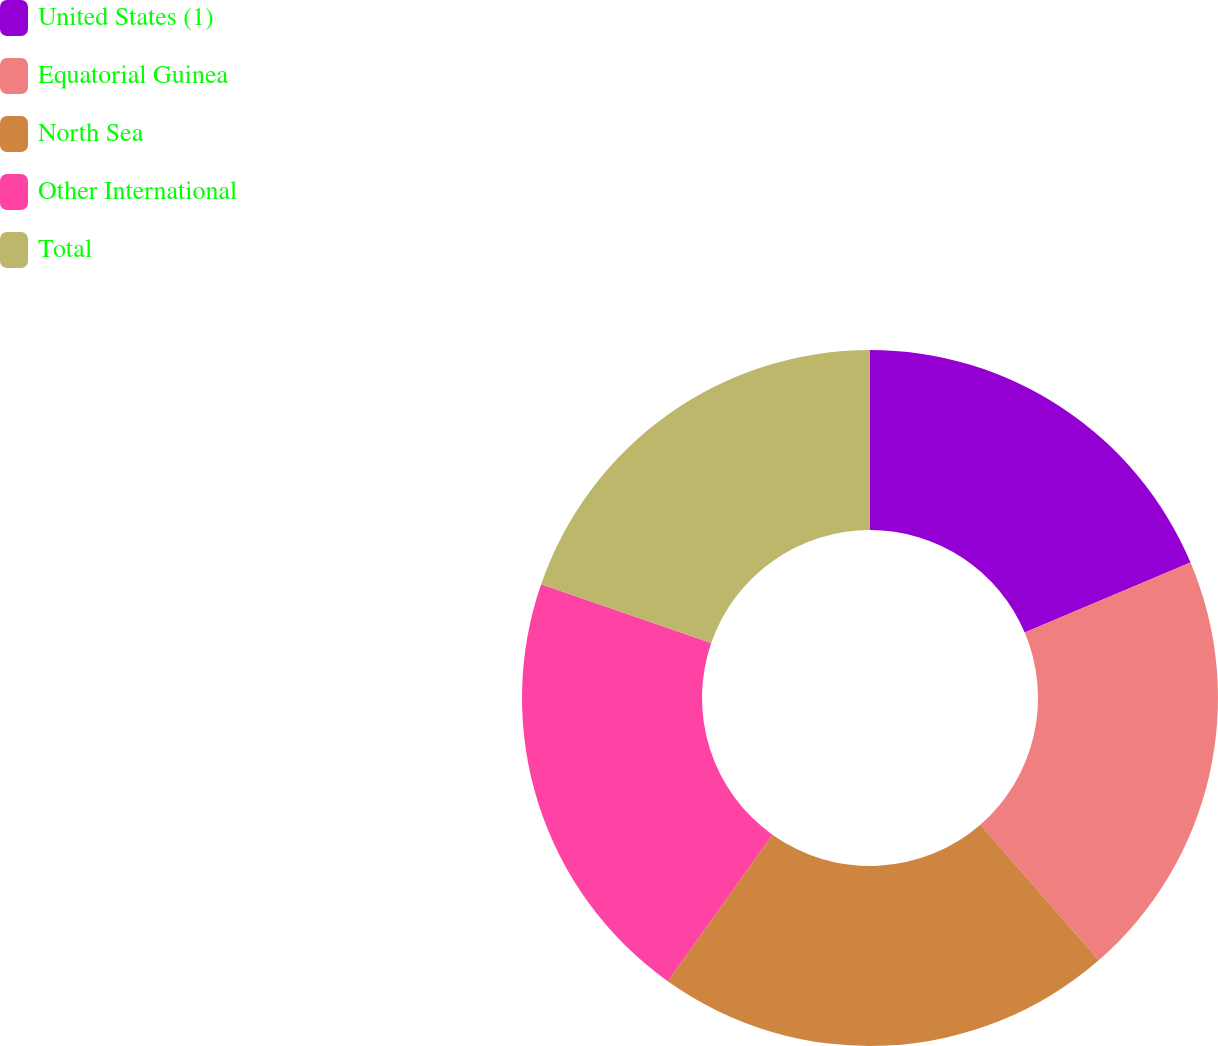Convert chart to OTSL. <chart><loc_0><loc_0><loc_500><loc_500><pie_chart><fcel>United States (1)<fcel>Equatorial Guinea<fcel>North Sea<fcel>Other International<fcel>Total<nl><fcel>18.63%<fcel>19.96%<fcel>21.28%<fcel>20.43%<fcel>19.7%<nl></chart> 